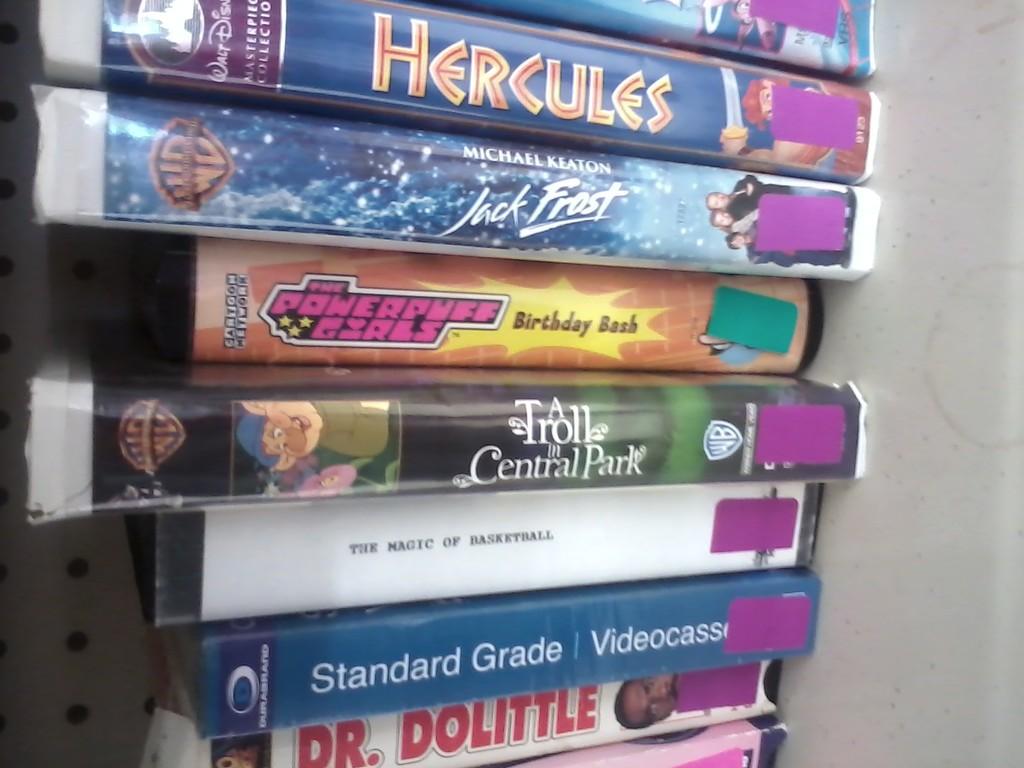Where is the troll located at in the movie?
Provide a short and direct response. Central park. Who stars in jack frost?
Provide a succinct answer. Michael keaton. 